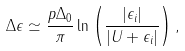<formula> <loc_0><loc_0><loc_500><loc_500>\Delta \epsilon \simeq \frac { p \Delta _ { 0 } } { \pi } \ln \left ( \frac { | \epsilon _ { i } | } { | U + \epsilon _ { i } | } \right ) ,</formula> 